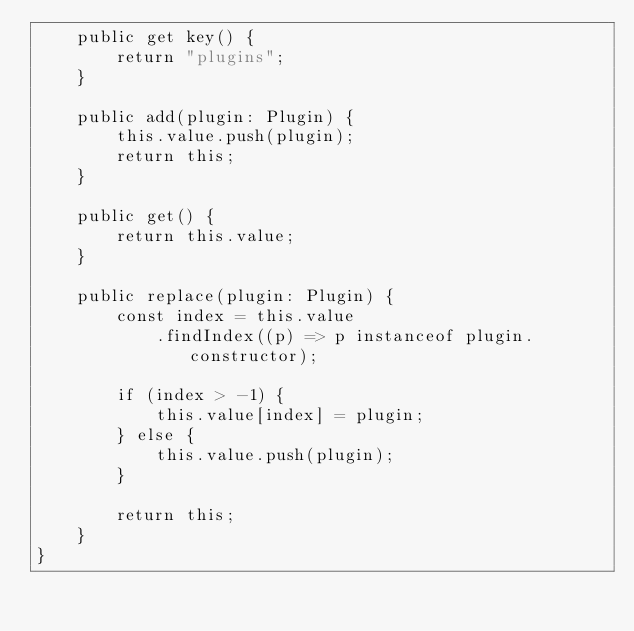<code> <loc_0><loc_0><loc_500><loc_500><_TypeScript_>    public get key() {
        return "plugins";
    }

    public add(plugin: Plugin) {
        this.value.push(plugin);
        return this;
    }

    public get() {
        return this.value;
    }

    public replace(plugin: Plugin) {
        const index = this.value
            .findIndex((p) => p instanceof plugin.constructor);

        if (index > -1) {
            this.value[index] = plugin;
        } else {
            this.value.push(plugin);
        }

        return this;
    }
}
</code> 